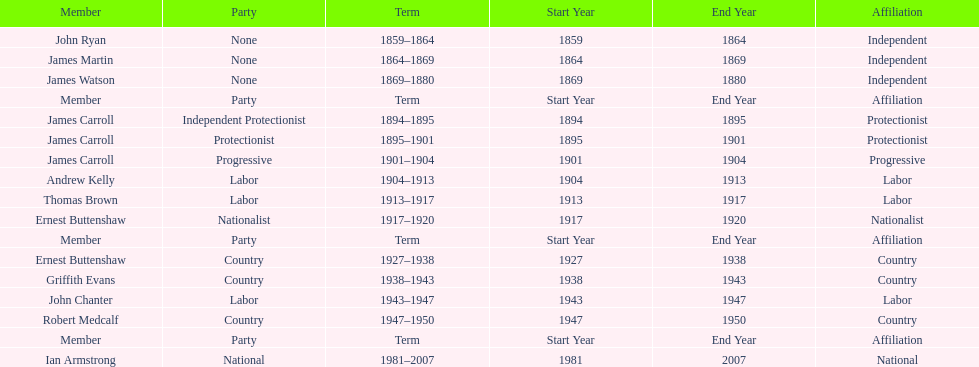How long did ian armstrong serve? 26 years. 